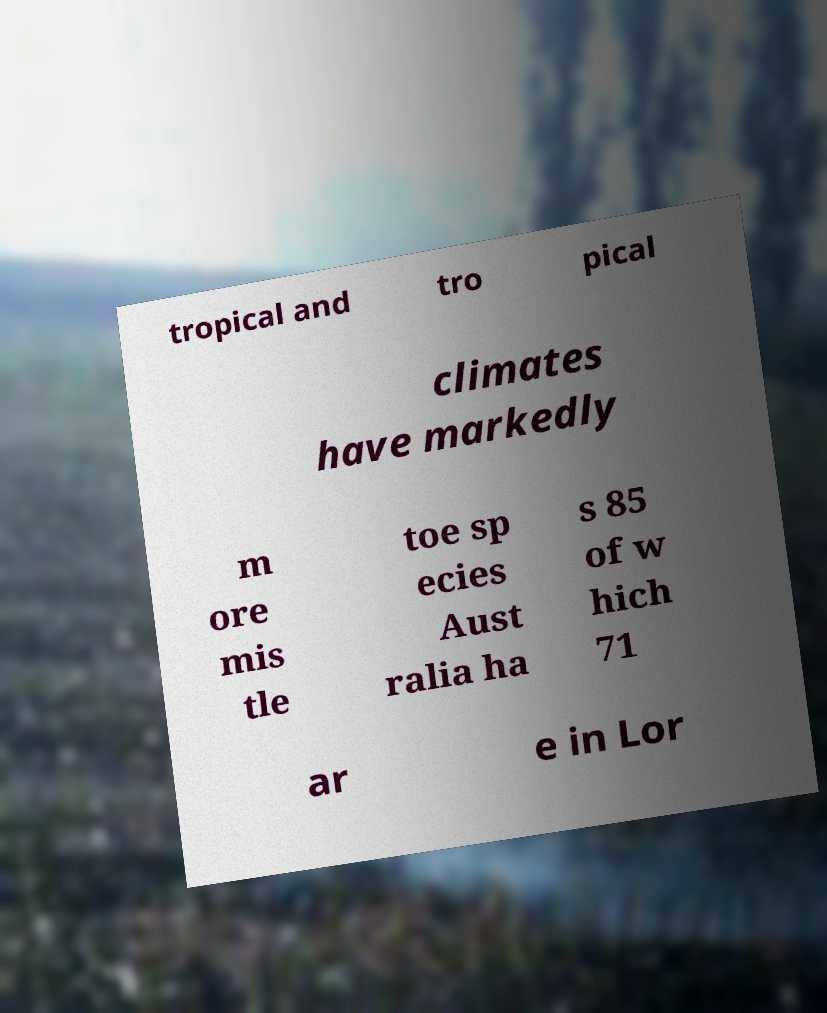Please read and relay the text visible in this image. What does it say? tropical and tro pical climates have markedly m ore mis tle toe sp ecies Aust ralia ha s 85 of w hich 71 ar e in Lor 